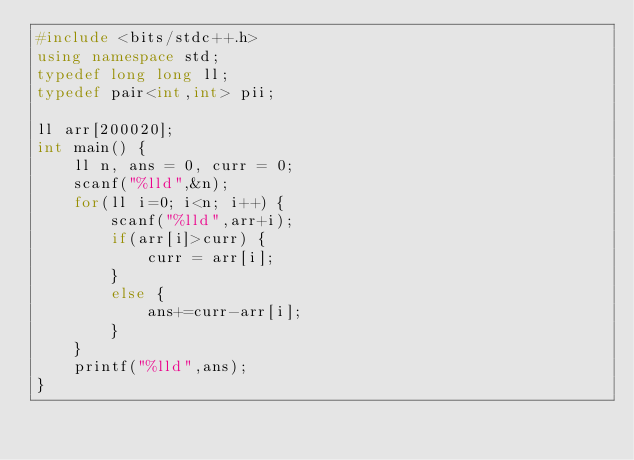<code> <loc_0><loc_0><loc_500><loc_500><_C++_>#include <bits/stdc++.h>
using namespace std;
typedef long long ll;
typedef pair<int,int> pii;

ll arr[200020];
int main() {
	ll n, ans = 0, curr = 0;
	scanf("%lld",&n);
	for(ll i=0; i<n; i++) {
		scanf("%lld",arr+i);
		if(arr[i]>curr) {
			curr = arr[i];
		}
		else {
			ans+=curr-arr[i];
		}
	}
	printf("%lld",ans);
}	

</code> 